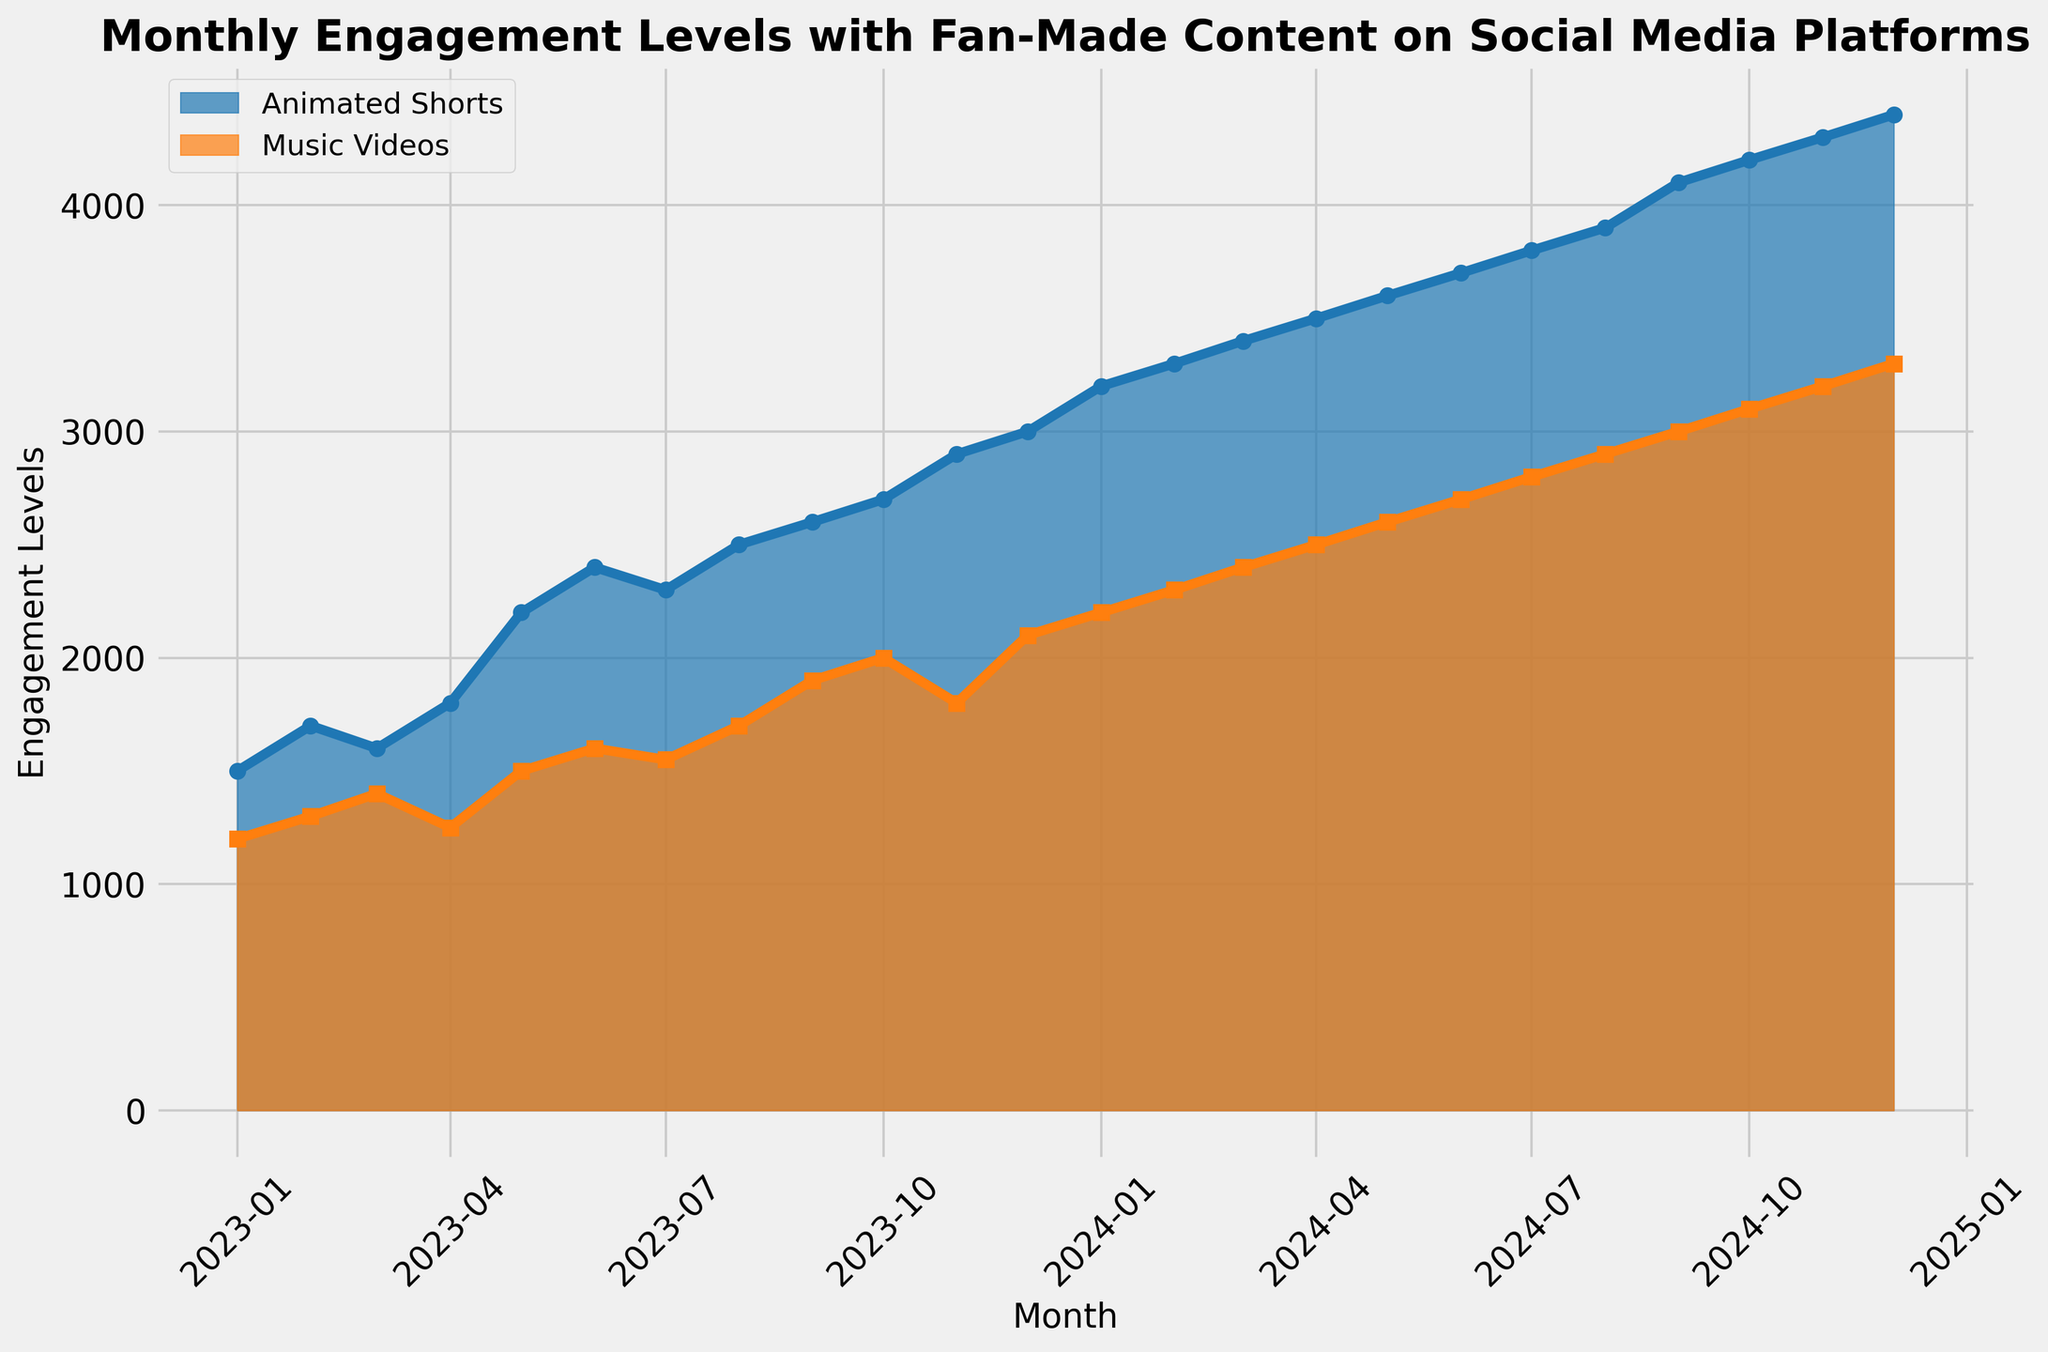What's the total engagement level for Animated Shorts and Music Videos in January 2024? To find the total engagement level, sum the engagement levels of both categories for January 2024. Animated Shorts had 3200 and Music Videos had 2200, so the total is 3200 + 2200 = 5400.
Answer: 5400 Which month saw the highest engagement level for Animated Shorts? The month with the highest engagement level for Animated Shorts is December 2024, which has an engagement level of 4400.
Answer: December 2024 In which month did Music Videos first surpass 2000 engagement levels? To find when Music Videos first surpassed 2000 engagement levels, look at the month-by-month data. Music Videos surpassed 2000 engagement levels in October 2023.
Answer: October 2023 Compare the engagement levels of Animated Shorts and Music Videos in September 2024. Which one is higher and by how much? In September 2024, Animated Shorts has an engagement level of 4100 and Music Videos has 3000. The difference is 4100 - 3000 = 1100, making Animated Shorts higher by 1100.
Answer: Animated Shorts by 1100 What is the average monthly engagement level for Music Videos over the entire period? To calculate the average, sum all monthly engagement levels for Music Videos and divide by the number of months. Sum: 1200 + 1300 + 1400 + 1250 + 1500 + 1600 + 1550 + 1700 + 1900 + 2000 + 1800 + 2100 + 2200 + 2300 + 2400 + 2500 + 2600 + 2700 + 2800 + 2900 + 3000 + 3100 + 3200 + 3300 = 56500. Number of months: 24. Average: 56500 / 24 = 2354.17.
Answer: 2354.17 By how much did the engagement level for Animated Shorts increase from January 2023 to December 2024? To find the increase, subtract the January 2023 engagement level from December 2024. January 2023 had 1500 and December 2024 had 4400. The increase is 4400 - 1500 = 2900.
Answer: 2900 Which content type had a more consistent growth pattern over the two years, and how can you tell? By observing the areas, Animated Shorts shows a steady and more consistent rise in engagement levels each month, compared to Music Videos, which fluctuates more.
Answer: Animated Shorts In which months are the engagement levels for Animated Shorts and Music Videos exactly equal? There are no months where the engagement levels for Animated Shorts and Music Videos are exactly equal.
Answer: None Calculate the total engagement level for both content types from January 2023 to December 2024. Sum the engagement levels of Animated Shorts and Music Videos across all months. Total for Animated Shorts: 1500 + 1700 + 1600 + 1800 + 2200 + 2400 + 2300 + 2500 + 2600 + 2700 + 2900 + 3000 + 3200 + 3300 + 3400 + 3500 + 3600 + 3700 + 3800 + 3900 + 4100 + 4200 + 4300 + 4400 = 77200. Total for Music Videos: 1200 + 1300 + 1400 + 1250 + 1500 + 1600 + 1550 + 1700 + 1900 + 2000 + 1800 + 2100 + 2200 + 2300 + 2400 + 2500 + 2600 + 2700 + 2800 + 2900 + 3000 + 3100 + 3200 + 3300 = 56500. Total overall: 77200 + 56500 = 133700.
Answer: 133700 